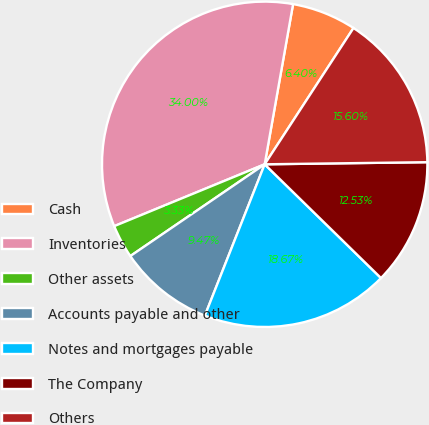Convert chart to OTSL. <chart><loc_0><loc_0><loc_500><loc_500><pie_chart><fcel>Cash<fcel>Inventories<fcel>Other assets<fcel>Accounts payable and other<fcel>Notes and mortgages payable<fcel>The Company<fcel>Others<nl><fcel>6.4%<fcel>34.0%<fcel>3.33%<fcel>9.47%<fcel>18.67%<fcel>12.53%<fcel>15.6%<nl></chart> 